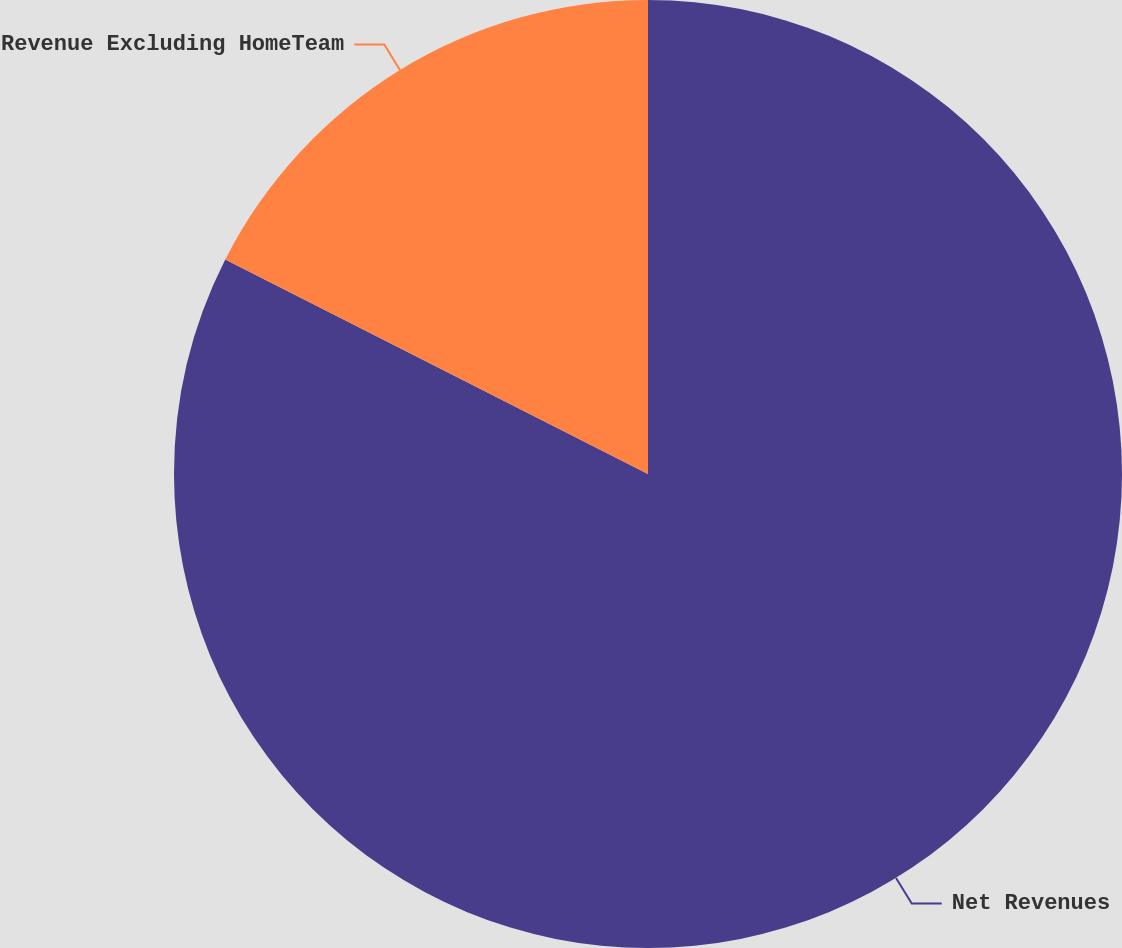Convert chart to OTSL. <chart><loc_0><loc_0><loc_500><loc_500><pie_chart><fcel>Net Revenues<fcel>Revenue Excluding HomeTeam<nl><fcel>82.47%<fcel>17.53%<nl></chart> 